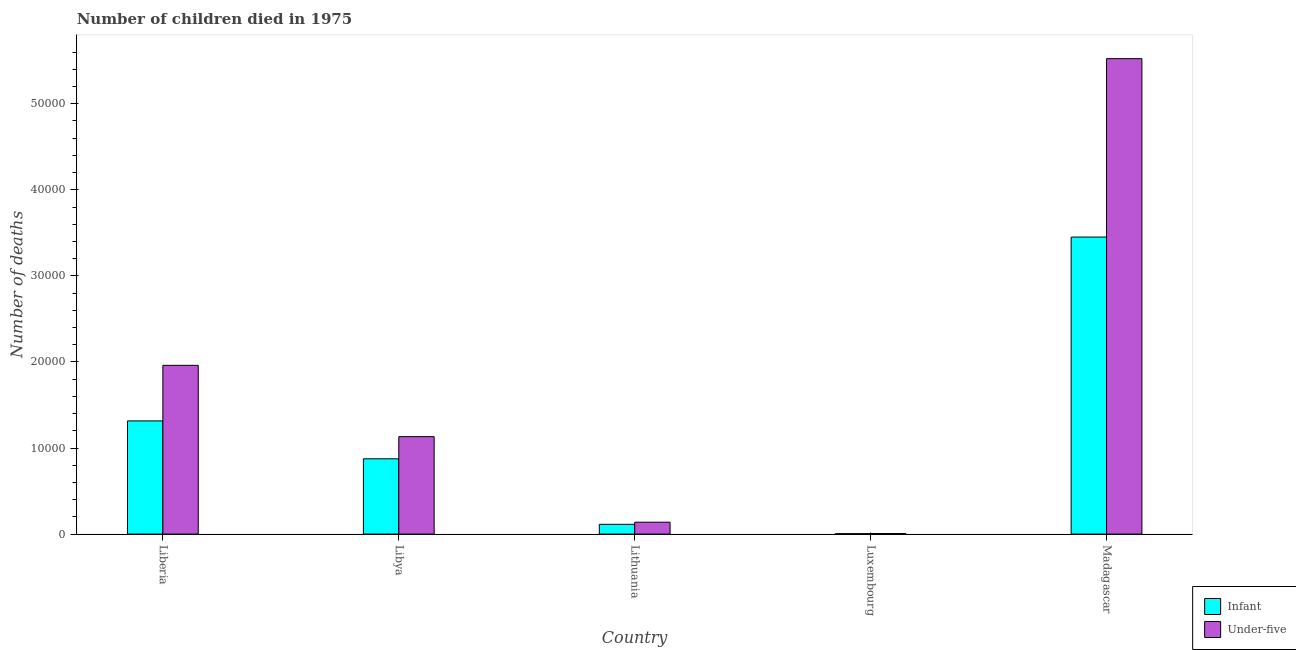Are the number of bars per tick equal to the number of legend labels?
Keep it short and to the point. Yes. Are the number of bars on each tick of the X-axis equal?
Give a very brief answer. Yes. How many bars are there on the 1st tick from the right?
Give a very brief answer. 2. What is the label of the 3rd group of bars from the left?
Keep it short and to the point. Lithuania. What is the number of infant deaths in Madagascar?
Keep it short and to the point. 3.45e+04. Across all countries, what is the maximum number of infant deaths?
Keep it short and to the point. 3.45e+04. Across all countries, what is the minimum number of under-five deaths?
Provide a short and direct response. 64. In which country was the number of infant deaths maximum?
Your answer should be compact. Madagascar. In which country was the number of under-five deaths minimum?
Your answer should be very brief. Luxembourg. What is the total number of infant deaths in the graph?
Your answer should be very brief. 5.76e+04. What is the difference between the number of under-five deaths in Libya and that in Lithuania?
Your answer should be very brief. 9938. What is the difference between the number of infant deaths in Madagascar and the number of under-five deaths in Libya?
Give a very brief answer. 2.32e+04. What is the average number of under-five deaths per country?
Provide a succinct answer. 1.75e+04. What is the difference between the number of infant deaths and number of under-five deaths in Lithuania?
Ensure brevity in your answer.  -248. In how many countries, is the number of under-five deaths greater than 40000 ?
Make the answer very short. 1. What is the ratio of the number of infant deaths in Liberia to that in Lithuania?
Your answer should be compact. 11.58. Is the difference between the number of under-five deaths in Lithuania and Luxembourg greater than the difference between the number of infant deaths in Lithuania and Luxembourg?
Your answer should be compact. Yes. What is the difference between the highest and the second highest number of under-five deaths?
Provide a succinct answer. 3.56e+04. What is the difference between the highest and the lowest number of under-five deaths?
Your response must be concise. 5.52e+04. In how many countries, is the number of infant deaths greater than the average number of infant deaths taken over all countries?
Your answer should be very brief. 2. Is the sum of the number of infant deaths in Liberia and Libya greater than the maximum number of under-five deaths across all countries?
Keep it short and to the point. No. What does the 1st bar from the left in Madagascar represents?
Ensure brevity in your answer.  Infant. What does the 1st bar from the right in Luxembourg represents?
Keep it short and to the point. Under-five. Where does the legend appear in the graph?
Your response must be concise. Bottom right. How are the legend labels stacked?
Provide a short and direct response. Vertical. What is the title of the graph?
Offer a terse response. Number of children died in 1975. What is the label or title of the X-axis?
Provide a short and direct response. Country. What is the label or title of the Y-axis?
Offer a very short reply. Number of deaths. What is the Number of deaths in Infant in Liberia?
Provide a succinct answer. 1.32e+04. What is the Number of deaths in Under-five in Liberia?
Offer a very short reply. 1.96e+04. What is the Number of deaths of Infant in Libya?
Your answer should be compact. 8748. What is the Number of deaths of Under-five in Libya?
Ensure brevity in your answer.  1.13e+04. What is the Number of deaths of Infant in Lithuania?
Your answer should be compact. 1136. What is the Number of deaths of Under-five in Lithuania?
Offer a terse response. 1384. What is the Number of deaths in Infant in Luxembourg?
Offer a terse response. 53. What is the Number of deaths in Infant in Madagascar?
Provide a short and direct response. 3.45e+04. What is the Number of deaths of Under-five in Madagascar?
Provide a succinct answer. 5.52e+04. Across all countries, what is the maximum Number of deaths of Infant?
Offer a terse response. 3.45e+04. Across all countries, what is the maximum Number of deaths of Under-five?
Keep it short and to the point. 5.52e+04. Across all countries, what is the minimum Number of deaths in Infant?
Offer a very short reply. 53. What is the total Number of deaths of Infant in the graph?
Your response must be concise. 5.76e+04. What is the total Number of deaths of Under-five in the graph?
Give a very brief answer. 8.76e+04. What is the difference between the Number of deaths of Infant in Liberia and that in Libya?
Give a very brief answer. 4402. What is the difference between the Number of deaths in Under-five in Liberia and that in Libya?
Make the answer very short. 8286. What is the difference between the Number of deaths in Infant in Liberia and that in Lithuania?
Ensure brevity in your answer.  1.20e+04. What is the difference between the Number of deaths in Under-five in Liberia and that in Lithuania?
Your response must be concise. 1.82e+04. What is the difference between the Number of deaths in Infant in Liberia and that in Luxembourg?
Your answer should be very brief. 1.31e+04. What is the difference between the Number of deaths in Under-five in Liberia and that in Luxembourg?
Keep it short and to the point. 1.95e+04. What is the difference between the Number of deaths of Infant in Liberia and that in Madagascar?
Your answer should be very brief. -2.14e+04. What is the difference between the Number of deaths in Under-five in Liberia and that in Madagascar?
Ensure brevity in your answer.  -3.56e+04. What is the difference between the Number of deaths in Infant in Libya and that in Lithuania?
Your answer should be very brief. 7612. What is the difference between the Number of deaths of Under-five in Libya and that in Lithuania?
Offer a very short reply. 9938. What is the difference between the Number of deaths of Infant in Libya and that in Luxembourg?
Provide a short and direct response. 8695. What is the difference between the Number of deaths in Under-five in Libya and that in Luxembourg?
Make the answer very short. 1.13e+04. What is the difference between the Number of deaths in Infant in Libya and that in Madagascar?
Give a very brief answer. -2.58e+04. What is the difference between the Number of deaths in Under-five in Libya and that in Madagascar?
Offer a terse response. -4.39e+04. What is the difference between the Number of deaths in Infant in Lithuania and that in Luxembourg?
Offer a very short reply. 1083. What is the difference between the Number of deaths in Under-five in Lithuania and that in Luxembourg?
Ensure brevity in your answer.  1320. What is the difference between the Number of deaths in Infant in Lithuania and that in Madagascar?
Your response must be concise. -3.34e+04. What is the difference between the Number of deaths in Under-five in Lithuania and that in Madagascar?
Provide a short and direct response. -5.39e+04. What is the difference between the Number of deaths of Infant in Luxembourg and that in Madagascar?
Provide a succinct answer. -3.45e+04. What is the difference between the Number of deaths in Under-five in Luxembourg and that in Madagascar?
Offer a terse response. -5.52e+04. What is the difference between the Number of deaths in Infant in Liberia and the Number of deaths in Under-five in Libya?
Offer a terse response. 1828. What is the difference between the Number of deaths in Infant in Liberia and the Number of deaths in Under-five in Lithuania?
Make the answer very short. 1.18e+04. What is the difference between the Number of deaths in Infant in Liberia and the Number of deaths in Under-five in Luxembourg?
Give a very brief answer. 1.31e+04. What is the difference between the Number of deaths in Infant in Liberia and the Number of deaths in Under-five in Madagascar?
Give a very brief answer. -4.21e+04. What is the difference between the Number of deaths of Infant in Libya and the Number of deaths of Under-five in Lithuania?
Your answer should be compact. 7364. What is the difference between the Number of deaths in Infant in Libya and the Number of deaths in Under-five in Luxembourg?
Make the answer very short. 8684. What is the difference between the Number of deaths in Infant in Libya and the Number of deaths in Under-five in Madagascar?
Your answer should be very brief. -4.65e+04. What is the difference between the Number of deaths in Infant in Lithuania and the Number of deaths in Under-five in Luxembourg?
Give a very brief answer. 1072. What is the difference between the Number of deaths in Infant in Lithuania and the Number of deaths in Under-five in Madagascar?
Make the answer very short. -5.41e+04. What is the difference between the Number of deaths in Infant in Luxembourg and the Number of deaths in Under-five in Madagascar?
Offer a terse response. -5.52e+04. What is the average Number of deaths in Infant per country?
Offer a very short reply. 1.15e+04. What is the average Number of deaths of Under-five per country?
Give a very brief answer. 1.75e+04. What is the difference between the Number of deaths in Infant and Number of deaths in Under-five in Liberia?
Your response must be concise. -6458. What is the difference between the Number of deaths in Infant and Number of deaths in Under-five in Libya?
Give a very brief answer. -2574. What is the difference between the Number of deaths of Infant and Number of deaths of Under-five in Lithuania?
Your answer should be very brief. -248. What is the difference between the Number of deaths in Infant and Number of deaths in Under-five in Madagascar?
Offer a terse response. -2.07e+04. What is the ratio of the Number of deaths in Infant in Liberia to that in Libya?
Make the answer very short. 1.5. What is the ratio of the Number of deaths of Under-five in Liberia to that in Libya?
Provide a succinct answer. 1.73. What is the ratio of the Number of deaths in Infant in Liberia to that in Lithuania?
Offer a very short reply. 11.58. What is the ratio of the Number of deaths of Under-five in Liberia to that in Lithuania?
Offer a terse response. 14.17. What is the ratio of the Number of deaths of Infant in Liberia to that in Luxembourg?
Your response must be concise. 248.11. What is the ratio of the Number of deaths of Under-five in Liberia to that in Luxembourg?
Keep it short and to the point. 306.38. What is the ratio of the Number of deaths of Infant in Liberia to that in Madagascar?
Ensure brevity in your answer.  0.38. What is the ratio of the Number of deaths of Under-five in Liberia to that in Madagascar?
Your response must be concise. 0.35. What is the ratio of the Number of deaths in Infant in Libya to that in Lithuania?
Offer a terse response. 7.7. What is the ratio of the Number of deaths in Under-five in Libya to that in Lithuania?
Give a very brief answer. 8.18. What is the ratio of the Number of deaths in Infant in Libya to that in Luxembourg?
Ensure brevity in your answer.  165.06. What is the ratio of the Number of deaths in Under-five in Libya to that in Luxembourg?
Make the answer very short. 176.91. What is the ratio of the Number of deaths of Infant in Libya to that in Madagascar?
Your answer should be compact. 0.25. What is the ratio of the Number of deaths of Under-five in Libya to that in Madagascar?
Your response must be concise. 0.2. What is the ratio of the Number of deaths of Infant in Lithuania to that in Luxembourg?
Offer a terse response. 21.43. What is the ratio of the Number of deaths in Under-five in Lithuania to that in Luxembourg?
Your answer should be compact. 21.62. What is the ratio of the Number of deaths of Infant in Lithuania to that in Madagascar?
Your response must be concise. 0.03. What is the ratio of the Number of deaths of Under-five in Lithuania to that in Madagascar?
Provide a succinct answer. 0.03. What is the ratio of the Number of deaths of Infant in Luxembourg to that in Madagascar?
Make the answer very short. 0. What is the ratio of the Number of deaths of Under-five in Luxembourg to that in Madagascar?
Your answer should be very brief. 0. What is the difference between the highest and the second highest Number of deaths in Infant?
Your answer should be very brief. 2.14e+04. What is the difference between the highest and the second highest Number of deaths of Under-five?
Your response must be concise. 3.56e+04. What is the difference between the highest and the lowest Number of deaths in Infant?
Your answer should be very brief. 3.45e+04. What is the difference between the highest and the lowest Number of deaths in Under-five?
Offer a terse response. 5.52e+04. 